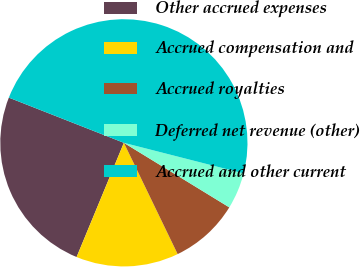Convert chart to OTSL. <chart><loc_0><loc_0><loc_500><loc_500><pie_chart><fcel>Other accrued expenses<fcel>Accrued compensation and<fcel>Accrued royalties<fcel>Deferred net revenue (other)<fcel>Accrued and other current<nl><fcel>24.71%<fcel>13.41%<fcel>9.09%<fcel>4.76%<fcel>48.02%<nl></chart> 